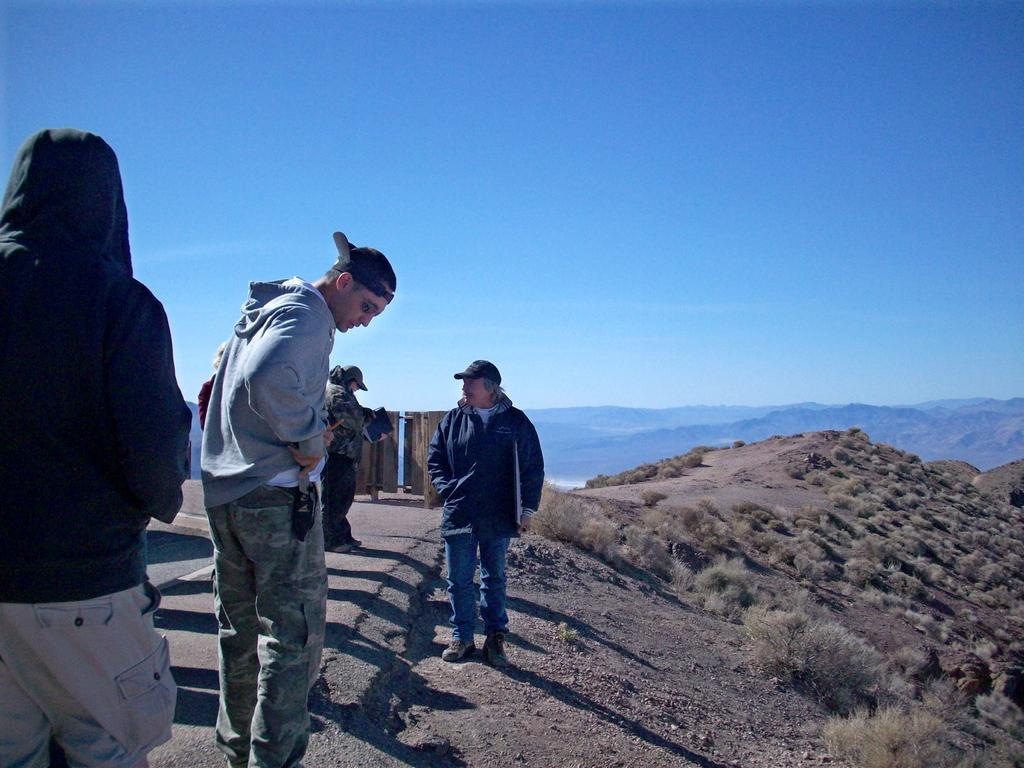What is the main subject of the image? The main subject of the image is a group of people. How can you describe the clothing of the people in the image? The people are wearing different color dresses. What type of natural environment can be seen to the right of the image? There is grass visible to the right of the image. What can be seen in the background of the image? There are mountains and the sky visible in the background of the image. What type of control panel can be seen in the image? There is no control panel present in the image; it features a group of people in different color dresses, grass, mountains, and the sky. What type of cub is visible in the image? There is no cub present in the image. 